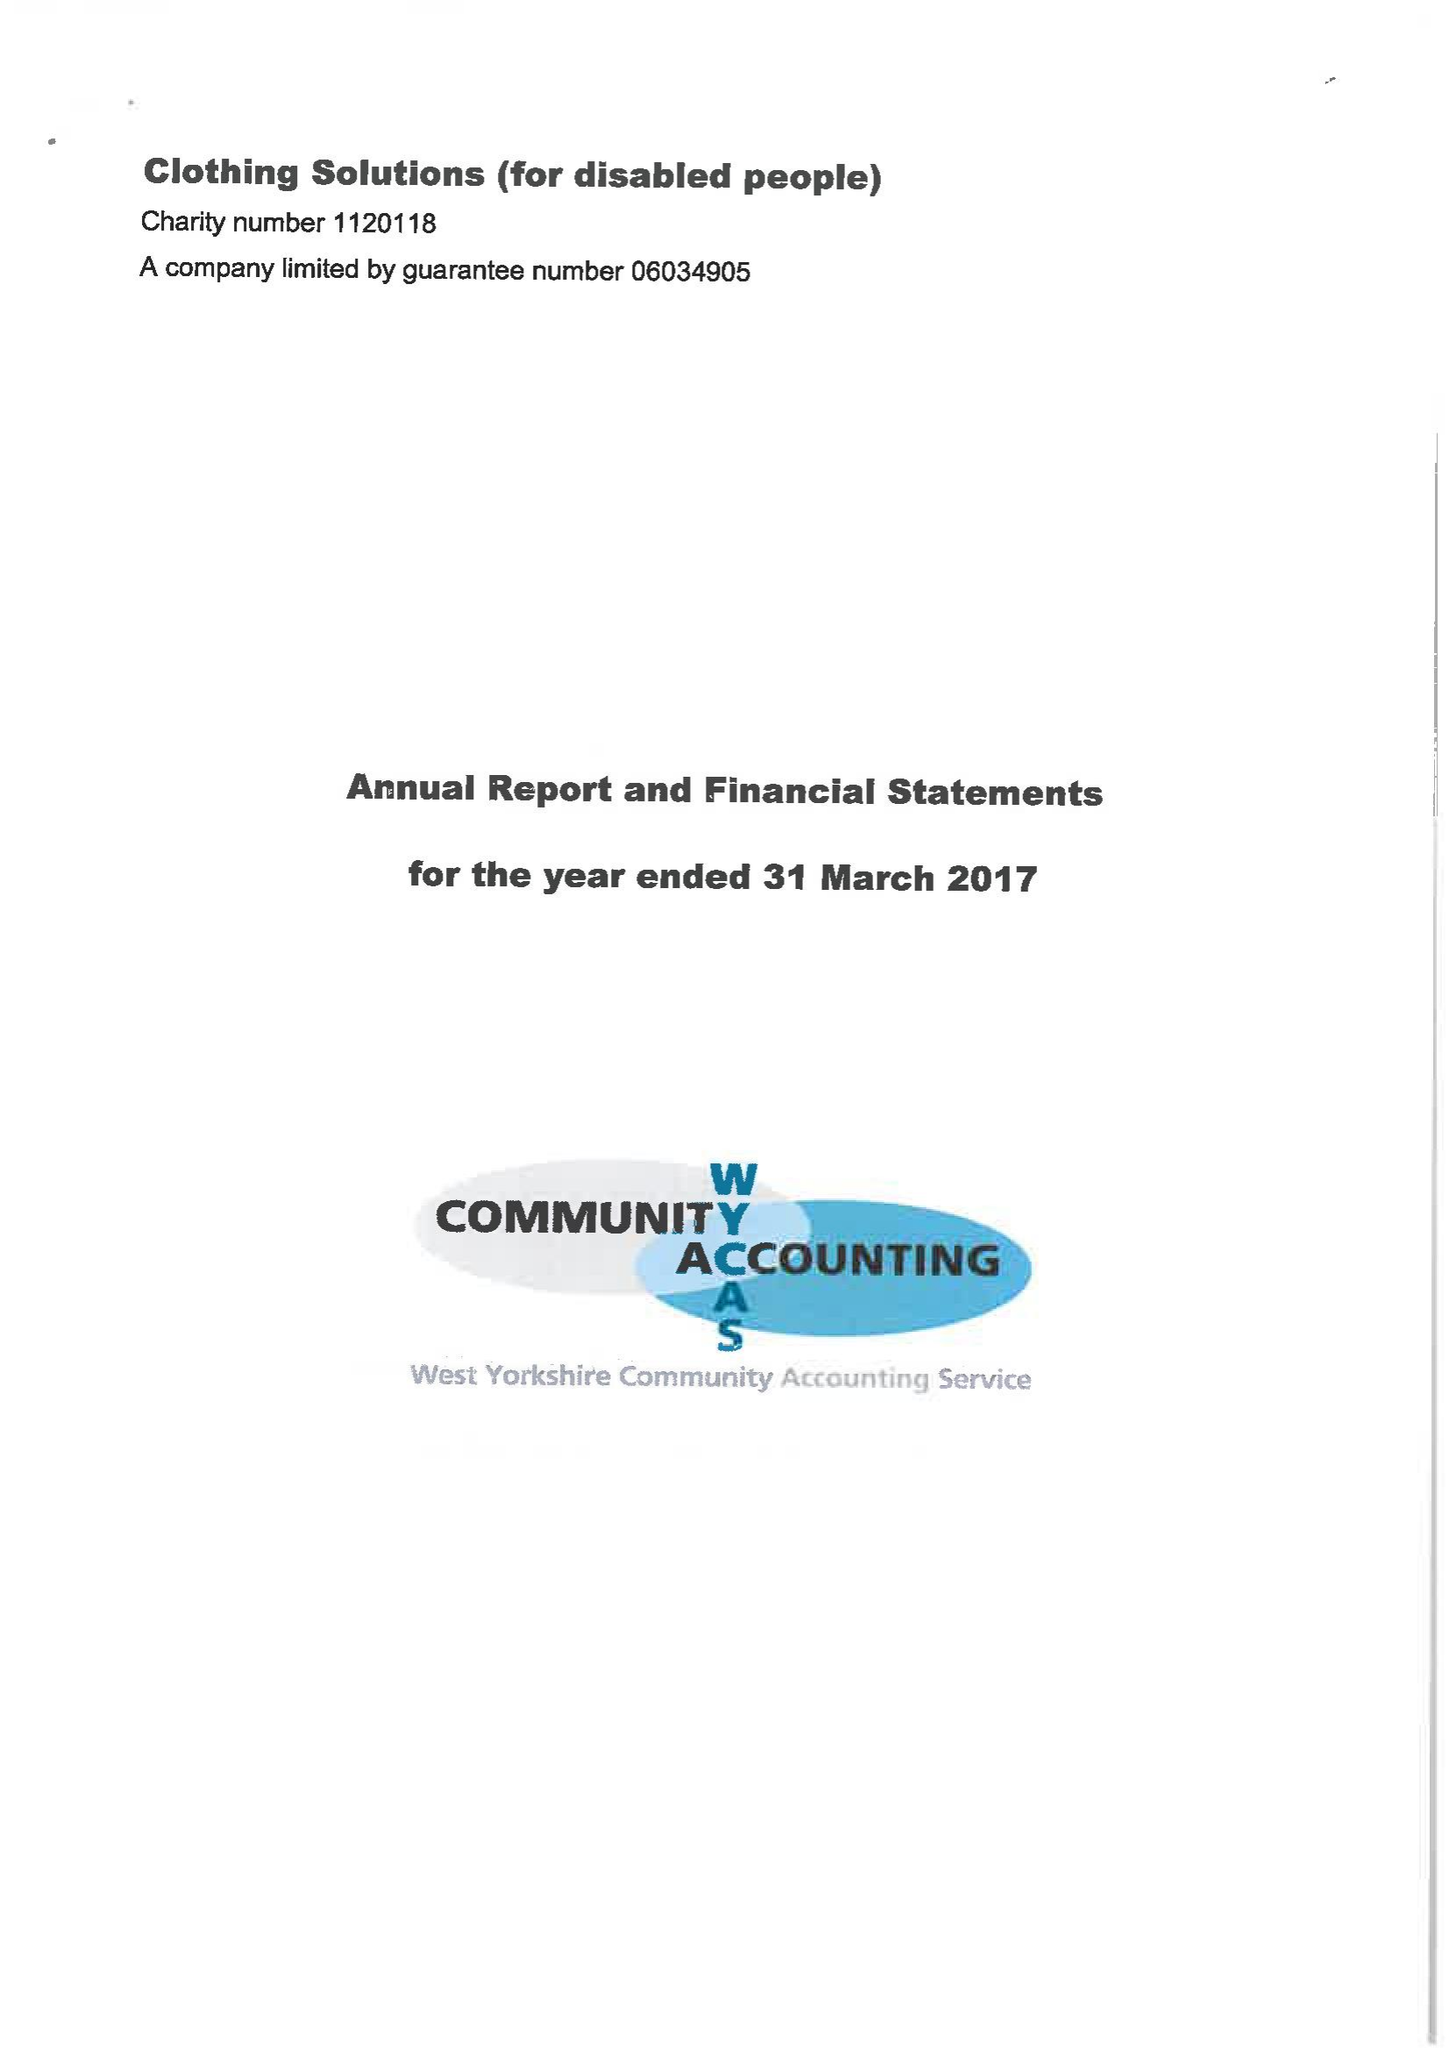What is the value for the spending_annually_in_british_pounds?
Answer the question using a single word or phrase. 101118.00 